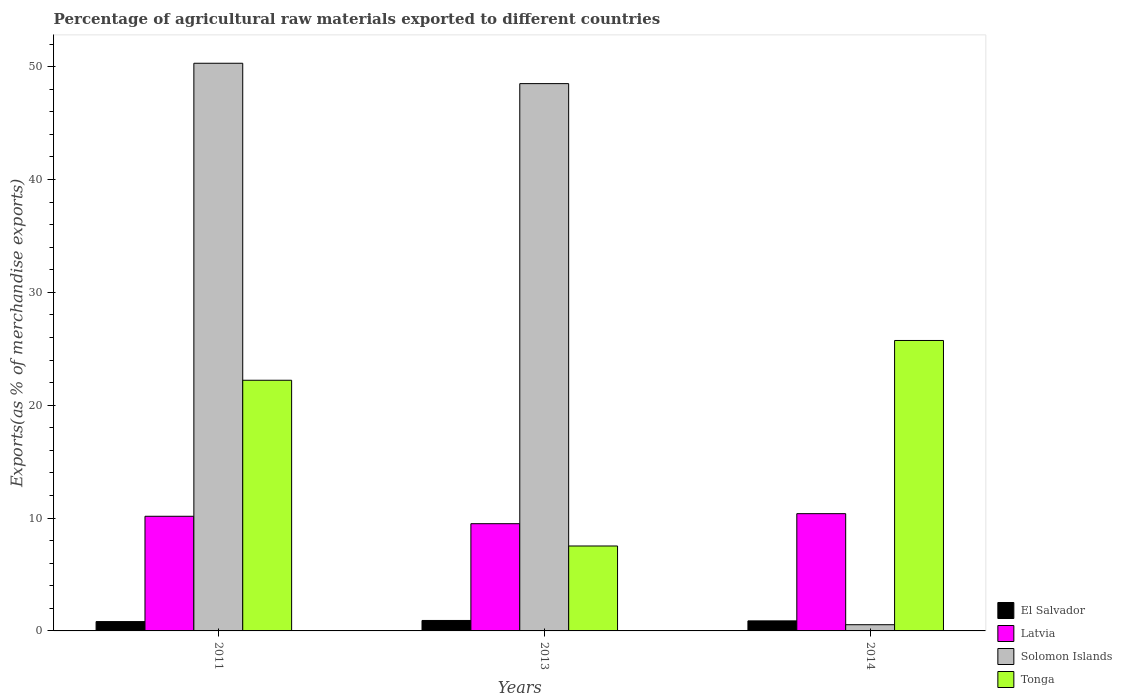Are the number of bars on each tick of the X-axis equal?
Give a very brief answer. Yes. How many bars are there on the 1st tick from the left?
Your answer should be compact. 4. What is the label of the 2nd group of bars from the left?
Give a very brief answer. 2013. In how many cases, is the number of bars for a given year not equal to the number of legend labels?
Keep it short and to the point. 0. What is the percentage of exports to different countries in El Salvador in 2013?
Make the answer very short. 0.93. Across all years, what is the maximum percentage of exports to different countries in Latvia?
Give a very brief answer. 10.39. Across all years, what is the minimum percentage of exports to different countries in Tonga?
Provide a succinct answer. 7.53. In which year was the percentage of exports to different countries in Tonga minimum?
Give a very brief answer. 2013. What is the total percentage of exports to different countries in Tonga in the graph?
Your response must be concise. 55.47. What is the difference between the percentage of exports to different countries in Tonga in 2011 and that in 2013?
Your answer should be compact. 14.68. What is the difference between the percentage of exports to different countries in Solomon Islands in 2011 and the percentage of exports to different countries in El Salvador in 2014?
Provide a short and direct response. 49.41. What is the average percentage of exports to different countries in El Salvador per year?
Your answer should be compact. 0.88. In the year 2013, what is the difference between the percentage of exports to different countries in El Salvador and percentage of exports to different countries in Tonga?
Give a very brief answer. -6.6. What is the ratio of the percentage of exports to different countries in Latvia in 2011 to that in 2014?
Keep it short and to the point. 0.98. Is the difference between the percentage of exports to different countries in El Salvador in 2011 and 2014 greater than the difference between the percentage of exports to different countries in Tonga in 2011 and 2014?
Provide a succinct answer. Yes. What is the difference between the highest and the second highest percentage of exports to different countries in Latvia?
Your answer should be very brief. 0.23. What is the difference between the highest and the lowest percentage of exports to different countries in Solomon Islands?
Provide a short and direct response. 49.75. Is it the case that in every year, the sum of the percentage of exports to different countries in El Salvador and percentage of exports to different countries in Tonga is greater than the sum of percentage of exports to different countries in Solomon Islands and percentage of exports to different countries in Latvia?
Offer a terse response. No. What does the 1st bar from the left in 2013 represents?
Offer a very short reply. El Salvador. What does the 1st bar from the right in 2011 represents?
Provide a succinct answer. Tonga. Is it the case that in every year, the sum of the percentage of exports to different countries in Latvia and percentage of exports to different countries in Solomon Islands is greater than the percentage of exports to different countries in Tonga?
Your answer should be very brief. No. Are all the bars in the graph horizontal?
Keep it short and to the point. No. How many years are there in the graph?
Provide a succinct answer. 3. Are the values on the major ticks of Y-axis written in scientific E-notation?
Offer a very short reply. No. Does the graph contain grids?
Your response must be concise. No. Where does the legend appear in the graph?
Give a very brief answer. Bottom right. How many legend labels are there?
Ensure brevity in your answer.  4. How are the legend labels stacked?
Offer a terse response. Vertical. What is the title of the graph?
Provide a succinct answer. Percentage of agricultural raw materials exported to different countries. What is the label or title of the X-axis?
Your answer should be very brief. Years. What is the label or title of the Y-axis?
Your answer should be very brief. Exports(as % of merchandise exports). What is the Exports(as % of merchandise exports) in El Salvador in 2011?
Give a very brief answer. 0.83. What is the Exports(as % of merchandise exports) in Latvia in 2011?
Give a very brief answer. 10.16. What is the Exports(as % of merchandise exports) of Solomon Islands in 2011?
Provide a succinct answer. 50.3. What is the Exports(as % of merchandise exports) in Tonga in 2011?
Give a very brief answer. 22.21. What is the Exports(as % of merchandise exports) in El Salvador in 2013?
Ensure brevity in your answer.  0.93. What is the Exports(as % of merchandise exports) in Latvia in 2013?
Provide a succinct answer. 9.5. What is the Exports(as % of merchandise exports) of Solomon Islands in 2013?
Keep it short and to the point. 48.5. What is the Exports(as % of merchandise exports) of Tonga in 2013?
Keep it short and to the point. 7.53. What is the Exports(as % of merchandise exports) of El Salvador in 2014?
Offer a terse response. 0.89. What is the Exports(as % of merchandise exports) in Latvia in 2014?
Your answer should be compact. 10.39. What is the Exports(as % of merchandise exports) of Solomon Islands in 2014?
Your response must be concise. 0.55. What is the Exports(as % of merchandise exports) in Tonga in 2014?
Give a very brief answer. 25.74. Across all years, what is the maximum Exports(as % of merchandise exports) in El Salvador?
Your response must be concise. 0.93. Across all years, what is the maximum Exports(as % of merchandise exports) of Latvia?
Provide a succinct answer. 10.39. Across all years, what is the maximum Exports(as % of merchandise exports) of Solomon Islands?
Give a very brief answer. 50.3. Across all years, what is the maximum Exports(as % of merchandise exports) of Tonga?
Provide a succinct answer. 25.74. Across all years, what is the minimum Exports(as % of merchandise exports) of El Salvador?
Offer a very short reply. 0.83. Across all years, what is the minimum Exports(as % of merchandise exports) in Latvia?
Offer a terse response. 9.5. Across all years, what is the minimum Exports(as % of merchandise exports) of Solomon Islands?
Offer a terse response. 0.55. Across all years, what is the minimum Exports(as % of merchandise exports) in Tonga?
Provide a succinct answer. 7.53. What is the total Exports(as % of merchandise exports) in El Salvador in the graph?
Give a very brief answer. 2.64. What is the total Exports(as % of merchandise exports) of Latvia in the graph?
Your answer should be compact. 30.05. What is the total Exports(as % of merchandise exports) of Solomon Islands in the graph?
Ensure brevity in your answer.  99.35. What is the total Exports(as % of merchandise exports) in Tonga in the graph?
Offer a terse response. 55.47. What is the difference between the Exports(as % of merchandise exports) in El Salvador in 2011 and that in 2013?
Offer a terse response. -0.1. What is the difference between the Exports(as % of merchandise exports) in Latvia in 2011 and that in 2013?
Keep it short and to the point. 0.66. What is the difference between the Exports(as % of merchandise exports) in Solomon Islands in 2011 and that in 2013?
Your response must be concise. 1.8. What is the difference between the Exports(as % of merchandise exports) in Tonga in 2011 and that in 2013?
Keep it short and to the point. 14.69. What is the difference between the Exports(as % of merchandise exports) of El Salvador in 2011 and that in 2014?
Provide a succinct answer. -0.06. What is the difference between the Exports(as % of merchandise exports) of Latvia in 2011 and that in 2014?
Give a very brief answer. -0.23. What is the difference between the Exports(as % of merchandise exports) of Solomon Islands in 2011 and that in 2014?
Make the answer very short. 49.75. What is the difference between the Exports(as % of merchandise exports) in Tonga in 2011 and that in 2014?
Provide a succinct answer. -3.53. What is the difference between the Exports(as % of merchandise exports) of El Salvador in 2013 and that in 2014?
Your response must be concise. 0.04. What is the difference between the Exports(as % of merchandise exports) of Latvia in 2013 and that in 2014?
Provide a short and direct response. -0.89. What is the difference between the Exports(as % of merchandise exports) of Solomon Islands in 2013 and that in 2014?
Your answer should be compact. 47.95. What is the difference between the Exports(as % of merchandise exports) of Tonga in 2013 and that in 2014?
Offer a terse response. -18.21. What is the difference between the Exports(as % of merchandise exports) in El Salvador in 2011 and the Exports(as % of merchandise exports) in Latvia in 2013?
Make the answer very short. -8.67. What is the difference between the Exports(as % of merchandise exports) in El Salvador in 2011 and the Exports(as % of merchandise exports) in Solomon Islands in 2013?
Provide a short and direct response. -47.67. What is the difference between the Exports(as % of merchandise exports) of El Salvador in 2011 and the Exports(as % of merchandise exports) of Tonga in 2013?
Your answer should be compact. -6.7. What is the difference between the Exports(as % of merchandise exports) in Latvia in 2011 and the Exports(as % of merchandise exports) in Solomon Islands in 2013?
Offer a very short reply. -38.34. What is the difference between the Exports(as % of merchandise exports) in Latvia in 2011 and the Exports(as % of merchandise exports) in Tonga in 2013?
Provide a short and direct response. 2.63. What is the difference between the Exports(as % of merchandise exports) of Solomon Islands in 2011 and the Exports(as % of merchandise exports) of Tonga in 2013?
Ensure brevity in your answer.  42.78. What is the difference between the Exports(as % of merchandise exports) in El Salvador in 2011 and the Exports(as % of merchandise exports) in Latvia in 2014?
Ensure brevity in your answer.  -9.56. What is the difference between the Exports(as % of merchandise exports) in El Salvador in 2011 and the Exports(as % of merchandise exports) in Solomon Islands in 2014?
Offer a very short reply. 0.28. What is the difference between the Exports(as % of merchandise exports) in El Salvador in 2011 and the Exports(as % of merchandise exports) in Tonga in 2014?
Give a very brief answer. -24.91. What is the difference between the Exports(as % of merchandise exports) in Latvia in 2011 and the Exports(as % of merchandise exports) in Solomon Islands in 2014?
Offer a terse response. 9.61. What is the difference between the Exports(as % of merchandise exports) of Latvia in 2011 and the Exports(as % of merchandise exports) of Tonga in 2014?
Offer a very short reply. -15.58. What is the difference between the Exports(as % of merchandise exports) in Solomon Islands in 2011 and the Exports(as % of merchandise exports) in Tonga in 2014?
Offer a very short reply. 24.57. What is the difference between the Exports(as % of merchandise exports) in El Salvador in 2013 and the Exports(as % of merchandise exports) in Latvia in 2014?
Ensure brevity in your answer.  -9.46. What is the difference between the Exports(as % of merchandise exports) in El Salvador in 2013 and the Exports(as % of merchandise exports) in Solomon Islands in 2014?
Your answer should be very brief. 0.38. What is the difference between the Exports(as % of merchandise exports) in El Salvador in 2013 and the Exports(as % of merchandise exports) in Tonga in 2014?
Keep it short and to the point. -24.81. What is the difference between the Exports(as % of merchandise exports) of Latvia in 2013 and the Exports(as % of merchandise exports) of Solomon Islands in 2014?
Your answer should be very brief. 8.95. What is the difference between the Exports(as % of merchandise exports) in Latvia in 2013 and the Exports(as % of merchandise exports) in Tonga in 2014?
Provide a succinct answer. -16.23. What is the difference between the Exports(as % of merchandise exports) in Solomon Islands in 2013 and the Exports(as % of merchandise exports) in Tonga in 2014?
Make the answer very short. 22.76. What is the average Exports(as % of merchandise exports) of El Salvador per year?
Keep it short and to the point. 0.88. What is the average Exports(as % of merchandise exports) of Latvia per year?
Offer a terse response. 10.02. What is the average Exports(as % of merchandise exports) of Solomon Islands per year?
Offer a very short reply. 33.12. What is the average Exports(as % of merchandise exports) in Tonga per year?
Provide a short and direct response. 18.49. In the year 2011, what is the difference between the Exports(as % of merchandise exports) of El Salvador and Exports(as % of merchandise exports) of Latvia?
Ensure brevity in your answer.  -9.33. In the year 2011, what is the difference between the Exports(as % of merchandise exports) in El Salvador and Exports(as % of merchandise exports) in Solomon Islands?
Provide a succinct answer. -49.48. In the year 2011, what is the difference between the Exports(as % of merchandise exports) in El Salvador and Exports(as % of merchandise exports) in Tonga?
Ensure brevity in your answer.  -21.38. In the year 2011, what is the difference between the Exports(as % of merchandise exports) in Latvia and Exports(as % of merchandise exports) in Solomon Islands?
Your answer should be very brief. -40.14. In the year 2011, what is the difference between the Exports(as % of merchandise exports) in Latvia and Exports(as % of merchandise exports) in Tonga?
Your answer should be compact. -12.05. In the year 2011, what is the difference between the Exports(as % of merchandise exports) of Solomon Islands and Exports(as % of merchandise exports) of Tonga?
Make the answer very short. 28.09. In the year 2013, what is the difference between the Exports(as % of merchandise exports) of El Salvador and Exports(as % of merchandise exports) of Latvia?
Provide a succinct answer. -8.58. In the year 2013, what is the difference between the Exports(as % of merchandise exports) of El Salvador and Exports(as % of merchandise exports) of Solomon Islands?
Your answer should be very brief. -47.57. In the year 2013, what is the difference between the Exports(as % of merchandise exports) in El Salvador and Exports(as % of merchandise exports) in Tonga?
Offer a very short reply. -6.6. In the year 2013, what is the difference between the Exports(as % of merchandise exports) of Latvia and Exports(as % of merchandise exports) of Solomon Islands?
Keep it short and to the point. -39. In the year 2013, what is the difference between the Exports(as % of merchandise exports) of Latvia and Exports(as % of merchandise exports) of Tonga?
Your answer should be compact. 1.98. In the year 2013, what is the difference between the Exports(as % of merchandise exports) of Solomon Islands and Exports(as % of merchandise exports) of Tonga?
Provide a succinct answer. 40.97. In the year 2014, what is the difference between the Exports(as % of merchandise exports) in El Salvador and Exports(as % of merchandise exports) in Latvia?
Offer a terse response. -9.5. In the year 2014, what is the difference between the Exports(as % of merchandise exports) in El Salvador and Exports(as % of merchandise exports) in Solomon Islands?
Provide a succinct answer. 0.34. In the year 2014, what is the difference between the Exports(as % of merchandise exports) of El Salvador and Exports(as % of merchandise exports) of Tonga?
Provide a succinct answer. -24.85. In the year 2014, what is the difference between the Exports(as % of merchandise exports) of Latvia and Exports(as % of merchandise exports) of Solomon Islands?
Your response must be concise. 9.84. In the year 2014, what is the difference between the Exports(as % of merchandise exports) in Latvia and Exports(as % of merchandise exports) in Tonga?
Your answer should be compact. -15.35. In the year 2014, what is the difference between the Exports(as % of merchandise exports) in Solomon Islands and Exports(as % of merchandise exports) in Tonga?
Keep it short and to the point. -25.19. What is the ratio of the Exports(as % of merchandise exports) in El Salvador in 2011 to that in 2013?
Give a very brief answer. 0.89. What is the ratio of the Exports(as % of merchandise exports) in Latvia in 2011 to that in 2013?
Provide a short and direct response. 1.07. What is the ratio of the Exports(as % of merchandise exports) in Solomon Islands in 2011 to that in 2013?
Your answer should be very brief. 1.04. What is the ratio of the Exports(as % of merchandise exports) in Tonga in 2011 to that in 2013?
Ensure brevity in your answer.  2.95. What is the ratio of the Exports(as % of merchandise exports) of El Salvador in 2011 to that in 2014?
Offer a very short reply. 0.93. What is the ratio of the Exports(as % of merchandise exports) in Latvia in 2011 to that in 2014?
Offer a terse response. 0.98. What is the ratio of the Exports(as % of merchandise exports) of Solomon Islands in 2011 to that in 2014?
Make the answer very short. 91.36. What is the ratio of the Exports(as % of merchandise exports) in Tonga in 2011 to that in 2014?
Ensure brevity in your answer.  0.86. What is the ratio of the Exports(as % of merchandise exports) in El Salvador in 2013 to that in 2014?
Keep it short and to the point. 1.04. What is the ratio of the Exports(as % of merchandise exports) of Latvia in 2013 to that in 2014?
Offer a terse response. 0.91. What is the ratio of the Exports(as % of merchandise exports) of Solomon Islands in 2013 to that in 2014?
Offer a very short reply. 88.09. What is the ratio of the Exports(as % of merchandise exports) of Tonga in 2013 to that in 2014?
Offer a terse response. 0.29. What is the difference between the highest and the second highest Exports(as % of merchandise exports) in El Salvador?
Offer a terse response. 0.04. What is the difference between the highest and the second highest Exports(as % of merchandise exports) in Latvia?
Provide a succinct answer. 0.23. What is the difference between the highest and the second highest Exports(as % of merchandise exports) of Solomon Islands?
Your answer should be very brief. 1.8. What is the difference between the highest and the second highest Exports(as % of merchandise exports) in Tonga?
Provide a short and direct response. 3.53. What is the difference between the highest and the lowest Exports(as % of merchandise exports) of El Salvador?
Make the answer very short. 0.1. What is the difference between the highest and the lowest Exports(as % of merchandise exports) in Latvia?
Your answer should be compact. 0.89. What is the difference between the highest and the lowest Exports(as % of merchandise exports) in Solomon Islands?
Make the answer very short. 49.75. What is the difference between the highest and the lowest Exports(as % of merchandise exports) in Tonga?
Provide a succinct answer. 18.21. 